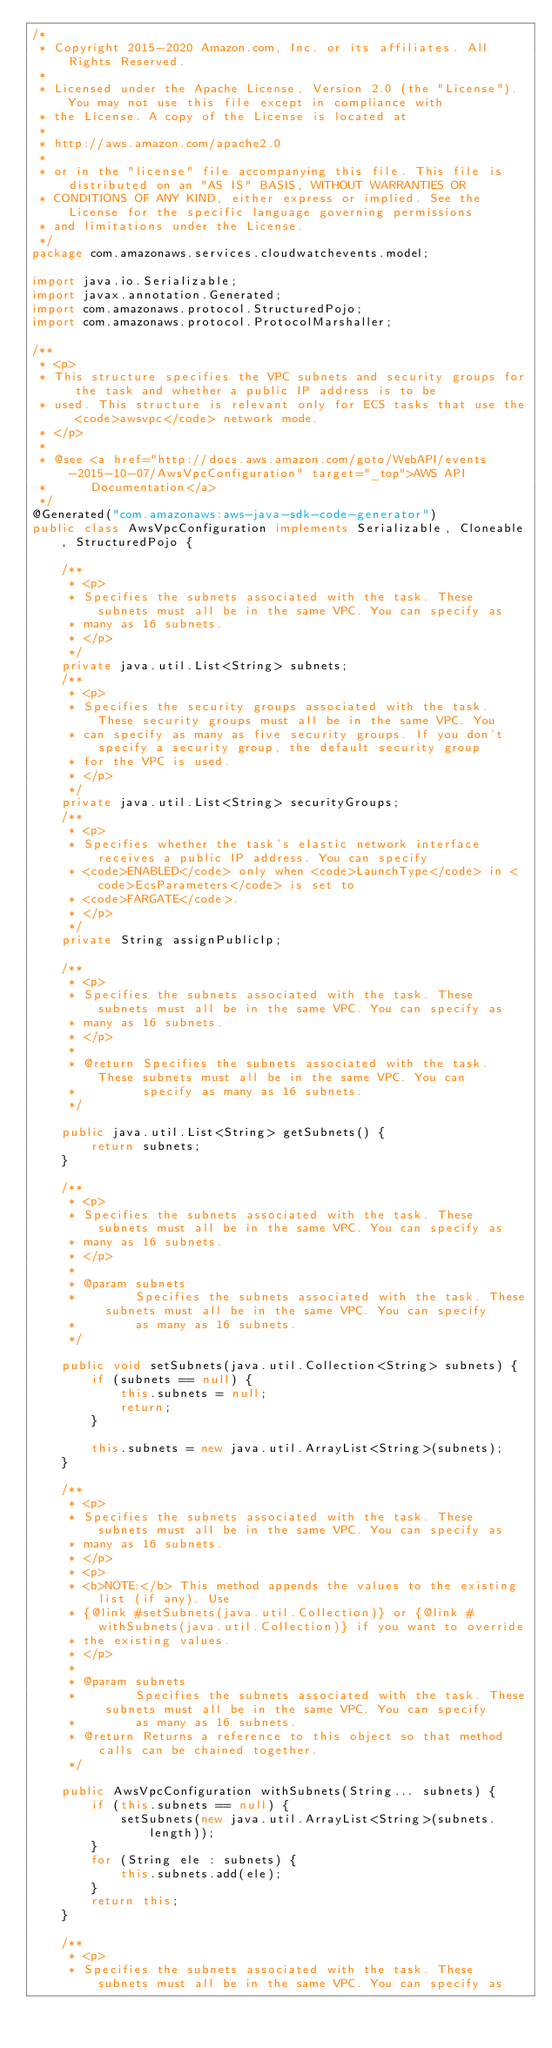Convert code to text. <code><loc_0><loc_0><loc_500><loc_500><_Java_>/*
 * Copyright 2015-2020 Amazon.com, Inc. or its affiliates. All Rights Reserved.
 * 
 * Licensed under the Apache License, Version 2.0 (the "License"). You may not use this file except in compliance with
 * the License. A copy of the License is located at
 * 
 * http://aws.amazon.com/apache2.0
 * 
 * or in the "license" file accompanying this file. This file is distributed on an "AS IS" BASIS, WITHOUT WARRANTIES OR
 * CONDITIONS OF ANY KIND, either express or implied. See the License for the specific language governing permissions
 * and limitations under the License.
 */
package com.amazonaws.services.cloudwatchevents.model;

import java.io.Serializable;
import javax.annotation.Generated;
import com.amazonaws.protocol.StructuredPojo;
import com.amazonaws.protocol.ProtocolMarshaller;

/**
 * <p>
 * This structure specifies the VPC subnets and security groups for the task and whether a public IP address is to be
 * used. This structure is relevant only for ECS tasks that use the <code>awsvpc</code> network mode.
 * </p>
 * 
 * @see <a href="http://docs.aws.amazon.com/goto/WebAPI/events-2015-10-07/AwsVpcConfiguration" target="_top">AWS API
 *      Documentation</a>
 */
@Generated("com.amazonaws:aws-java-sdk-code-generator")
public class AwsVpcConfiguration implements Serializable, Cloneable, StructuredPojo {

    /**
     * <p>
     * Specifies the subnets associated with the task. These subnets must all be in the same VPC. You can specify as
     * many as 16 subnets.
     * </p>
     */
    private java.util.List<String> subnets;
    /**
     * <p>
     * Specifies the security groups associated with the task. These security groups must all be in the same VPC. You
     * can specify as many as five security groups. If you don't specify a security group, the default security group
     * for the VPC is used.
     * </p>
     */
    private java.util.List<String> securityGroups;
    /**
     * <p>
     * Specifies whether the task's elastic network interface receives a public IP address. You can specify
     * <code>ENABLED</code> only when <code>LaunchType</code> in <code>EcsParameters</code> is set to
     * <code>FARGATE</code>.
     * </p>
     */
    private String assignPublicIp;

    /**
     * <p>
     * Specifies the subnets associated with the task. These subnets must all be in the same VPC. You can specify as
     * many as 16 subnets.
     * </p>
     * 
     * @return Specifies the subnets associated with the task. These subnets must all be in the same VPC. You can
     *         specify as many as 16 subnets.
     */

    public java.util.List<String> getSubnets() {
        return subnets;
    }

    /**
     * <p>
     * Specifies the subnets associated with the task. These subnets must all be in the same VPC. You can specify as
     * many as 16 subnets.
     * </p>
     * 
     * @param subnets
     *        Specifies the subnets associated with the task. These subnets must all be in the same VPC. You can specify
     *        as many as 16 subnets.
     */

    public void setSubnets(java.util.Collection<String> subnets) {
        if (subnets == null) {
            this.subnets = null;
            return;
        }

        this.subnets = new java.util.ArrayList<String>(subnets);
    }

    /**
     * <p>
     * Specifies the subnets associated with the task. These subnets must all be in the same VPC. You can specify as
     * many as 16 subnets.
     * </p>
     * <p>
     * <b>NOTE:</b> This method appends the values to the existing list (if any). Use
     * {@link #setSubnets(java.util.Collection)} or {@link #withSubnets(java.util.Collection)} if you want to override
     * the existing values.
     * </p>
     * 
     * @param subnets
     *        Specifies the subnets associated with the task. These subnets must all be in the same VPC. You can specify
     *        as many as 16 subnets.
     * @return Returns a reference to this object so that method calls can be chained together.
     */

    public AwsVpcConfiguration withSubnets(String... subnets) {
        if (this.subnets == null) {
            setSubnets(new java.util.ArrayList<String>(subnets.length));
        }
        for (String ele : subnets) {
            this.subnets.add(ele);
        }
        return this;
    }

    /**
     * <p>
     * Specifies the subnets associated with the task. These subnets must all be in the same VPC. You can specify as</code> 